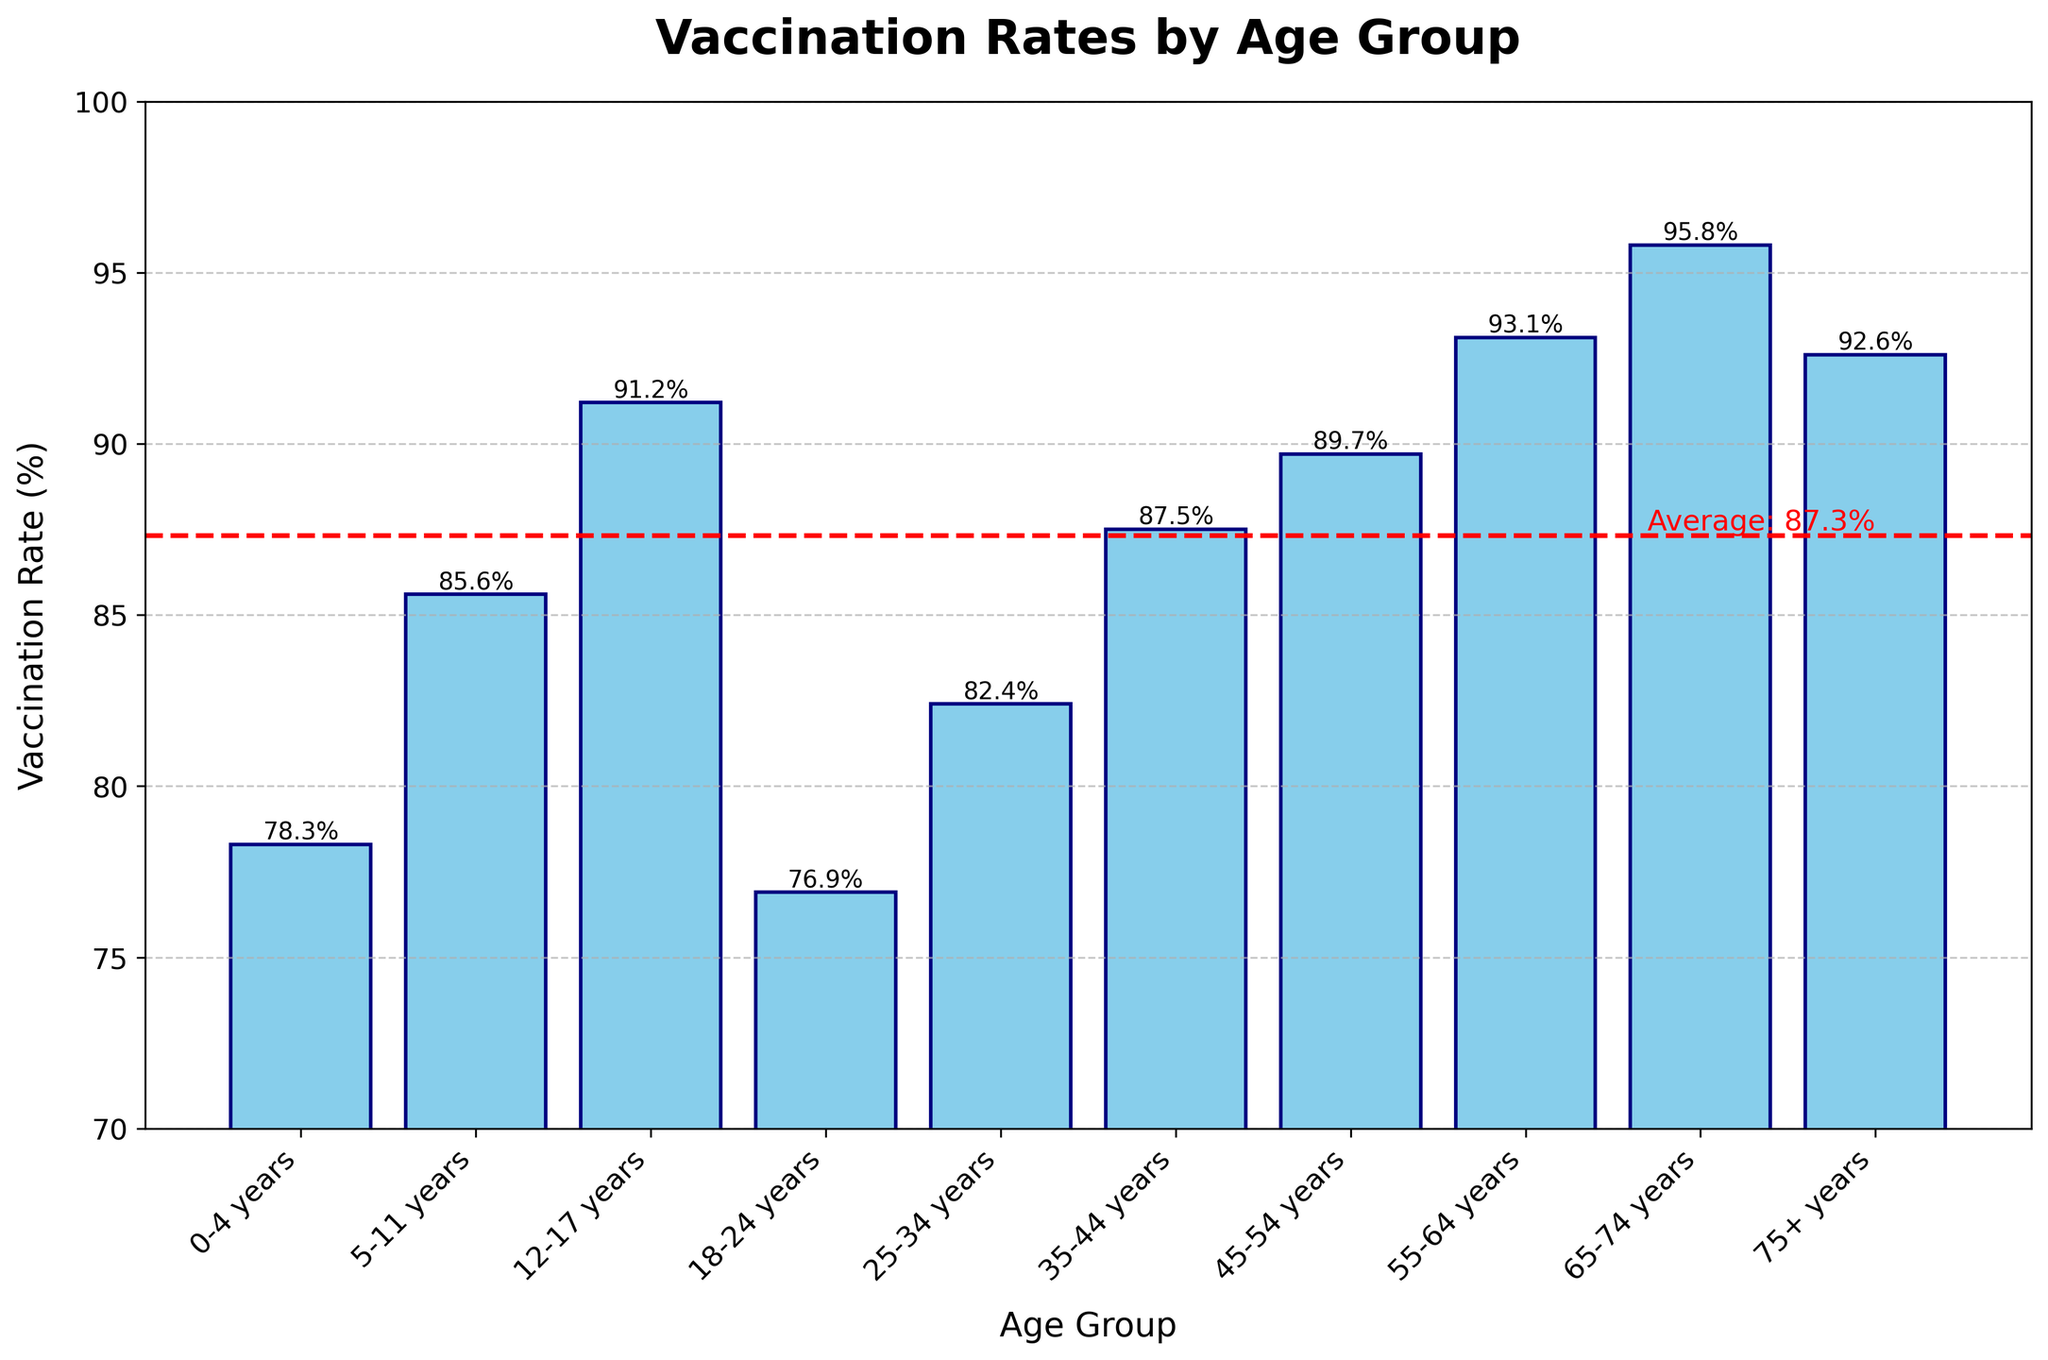Which age group has the highest vaccination rate? The figure shows a bar for each age group, and the height of the bar represents the vaccination rate. The highest bar corresponds to the 65-74 years group.
Answer: 65-74 years What is the average vaccination rate across all age groups? The average vaccination rate is indicated by a horizontal red dashed line on the figure. The label next to the line shows the average rate.
Answer: 87.5% How much higher is the vaccination rate for the 55-64 years age group compared to the 18-24 years age group? The vaccination rate for the 55-64 years age group is 93.1%, and for the 18-24 years age group, it is 76.9%. The difference is 93.1% - 76.9%.
Answer: 16.2% Which age groups have a vaccination rate higher than the average rate? Refer to the red dashed line showing the average rate. The bars that exceed this line correspond to groups with a vaccination rate higher than the average. These are the age groups with rates 91.2%, 87.5%, 89.7%, 93.1%, 95.8%, and 92.6%.
Answer: 12-17 years, 35-44 years, 45-54 years, 55-64 years, 65-74 years, 75+ years Compare the vaccination rates between the 5-11 years and 25-34 years age groups. The vaccination rate for the 5-11 years group is 85.6%, and for the 25-34 years group, it is 82.4%.
Answer: 5-11 years > 25-34 years What is the total vaccination rate for age groups below 18 years? The vaccination rates for the age groups under 18 years (0-4, 5-11, and 12-17) are 78.3%, 85.6%, and 91.2% respectively. Summing them up: 78.3 + 85.6 + 91.2.
Answer: 255.1% What's the median vaccination rate of all age groups? To find the median, list the vaccination rates in ascending order: 76.9%, 78.3%, 82.4%, 85.6%, 87.5%, 89.7%, 91.2%, 92.6%, 93.1%, 95.8%. The middle value (median) between the 5th and 6th rates is (87.5% + 89.7%) / 2.
Answer: 88.6% Which age group has the lowest vaccination rate? The lowest bar in the figure corresponds to the 18-24 years age group with a vaccination rate of 76.9%.
Answer: 18-24 years How does the vaccination rate for the 75+ years age group compare to that for the 0-4 years age group? The vaccination rate for the 75+ years group is 92.6%, and for the 0-4 years group, it is 78.3%.
Answer: 75+ years > 0-4 years 